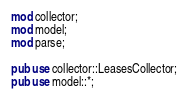Convert code to text. <code><loc_0><loc_0><loc_500><loc_500><_Rust_>mod collector;
mod model;
mod parse;

pub use collector::LeasesCollector;
pub use model::*;
</code> 